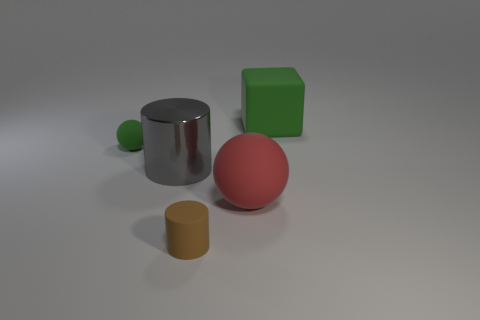Do the small rubber cylinder and the cube have the same color?
Ensure brevity in your answer.  No. What number of large cubes are right of the green matte ball?
Make the answer very short. 1. There is a big block that is the same material as the tiny green object; what is its color?
Your response must be concise. Green. How many rubber things are green balls or brown objects?
Your answer should be very brief. 2. Does the large cylinder have the same material as the small green object?
Provide a short and direct response. No. The green object on the left side of the brown thing has what shape?
Make the answer very short. Sphere. There is a small matte object that is behind the tiny cylinder; are there any gray objects that are on the left side of it?
Your answer should be compact. No. Are there any shiny cylinders that have the same size as the gray thing?
Your response must be concise. No. There is a large rubber thing that is left of the big green block; does it have the same color as the matte cylinder?
Ensure brevity in your answer.  No. The brown object is what size?
Provide a short and direct response. Small. 